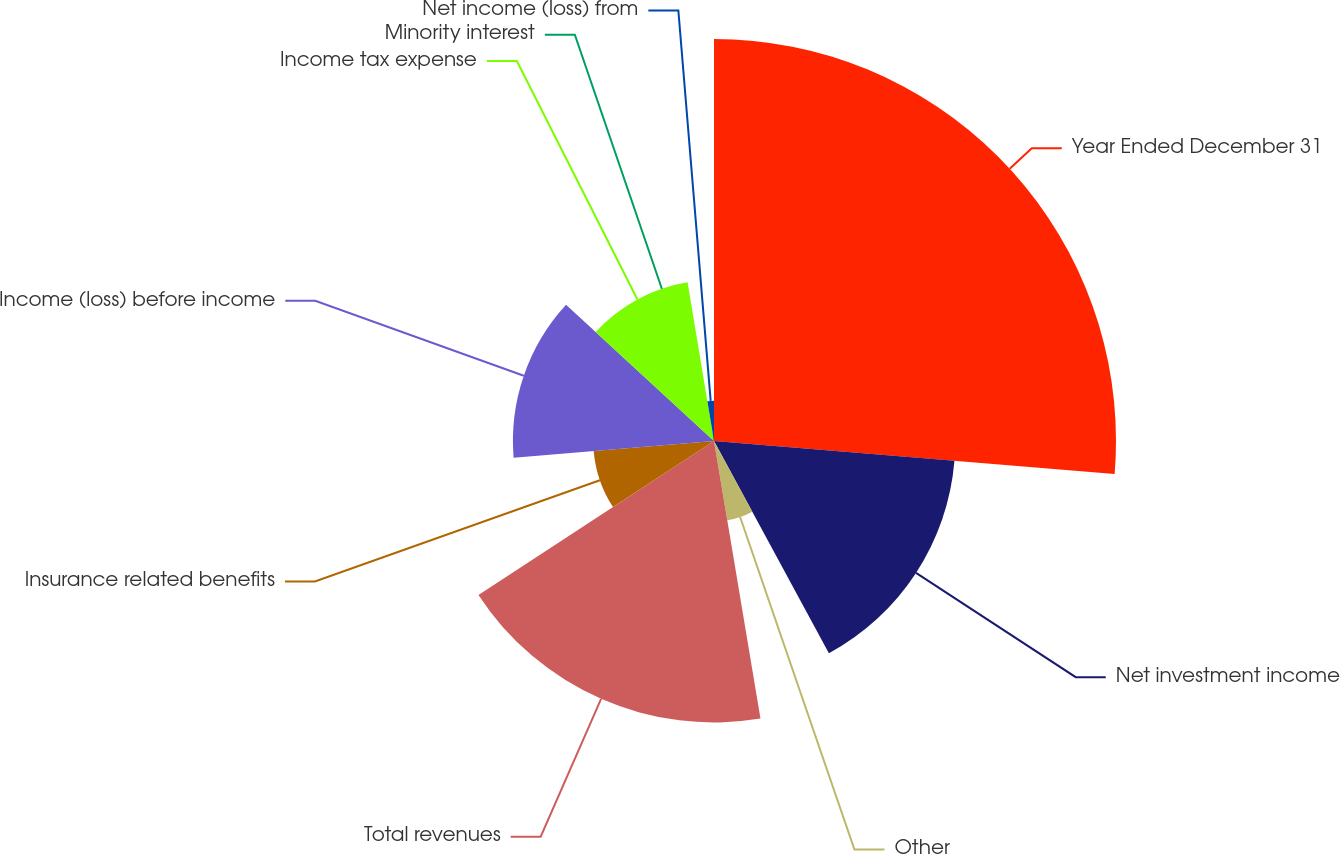Convert chart. <chart><loc_0><loc_0><loc_500><loc_500><pie_chart><fcel>Year Ended December 31<fcel>Net investment income<fcel>Other<fcel>Total revenues<fcel>Insurance related benefits<fcel>Income (loss) before income<fcel>Income tax expense<fcel>Minority interest<fcel>Net income (loss) from<nl><fcel>26.31%<fcel>15.79%<fcel>5.26%<fcel>18.42%<fcel>7.9%<fcel>13.16%<fcel>10.53%<fcel>0.0%<fcel>2.63%<nl></chart> 